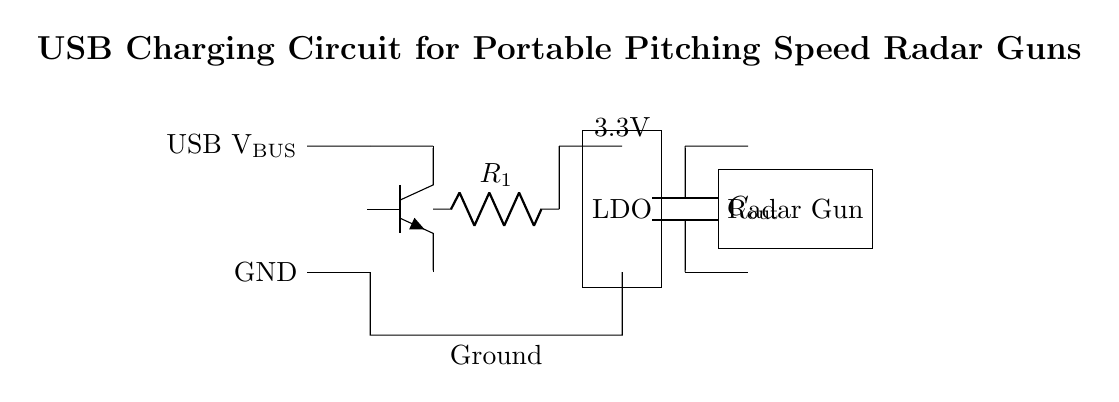What is the input voltage of this circuit? The input voltage is the USB VBUS, which typically provides 5 volts for charging. It is labeled in the circuit diagram.
Answer: 5 volts What type of voltage regulation component is used? The circuit uses an LDO (Low Drop-Out) regulator for voltage regulation, indicated within a rectangular box in the diagram.
Answer: LDO What is the output voltage of this circuit? The output voltage is labeled as 3.3 volts, indicating the voltage supplied to the radar gun after regulation.
Answer: 3.3 volts What is the purpose of the capacitor labeled C_out? The capacitor C_out is used for smoothing the output voltage, ensuring stable performance to the connected load, which is the radar gun.
Answer: Smoothing What is the load connected to the output of this circuit? The load connected is labeled as the Radar Gun, which is the device receiving power from the circuit.
Answer: Radar Gun How is the ground marked in this circuit? The ground is represented by a connection to the lower part of the circuit diagram, indicating the common return path for electric current.
Answer: GND What resistor is included in the circuit and its labeling? The circuit includes a resistor labeled R_1, which typically provides current limiting or feedback for the voltage regulation.
Answer: R_1 